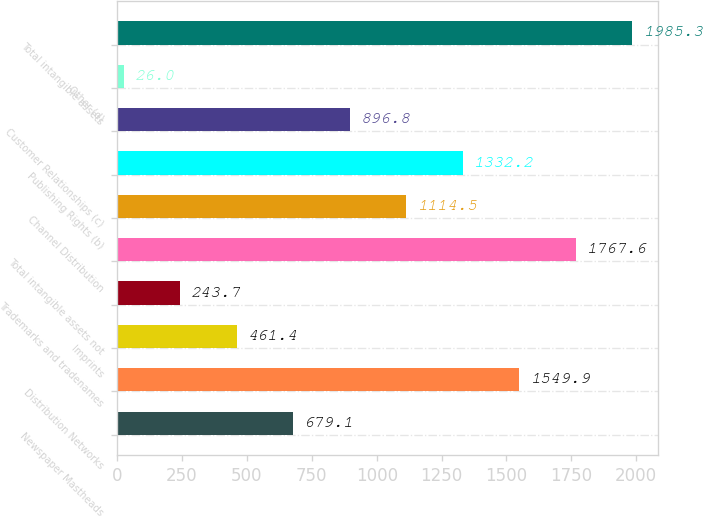Convert chart. <chart><loc_0><loc_0><loc_500><loc_500><bar_chart><fcel>Newspaper Mastheads<fcel>Distribution Networks<fcel>Imprints<fcel>Trademarks and tradenames<fcel>Total intangible assets not<fcel>Channel Distribution<fcel>Publishing Rights (b)<fcel>Customer Relationships (c)<fcel>Other (d)<fcel>Total intangible assets<nl><fcel>679.1<fcel>1549.9<fcel>461.4<fcel>243.7<fcel>1767.6<fcel>1114.5<fcel>1332.2<fcel>896.8<fcel>26<fcel>1985.3<nl></chart> 